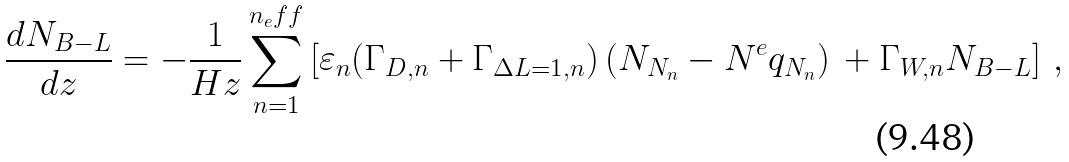<formula> <loc_0><loc_0><loc_500><loc_500>\frac { d N _ { B - L } } { d z } = - \frac { 1 } { H z } \sum _ { n = 1 } ^ { n _ { e } f f } \left [ \varepsilon _ { n } ( \Gamma _ { D , n } + \Gamma _ { \Delta L = 1 , n } ) \, ( N _ { N _ { n } } - N ^ { e } q _ { N _ { n } } ) \, + \Gamma _ { W , n } N _ { B - L } \right ] \, ,</formula> 